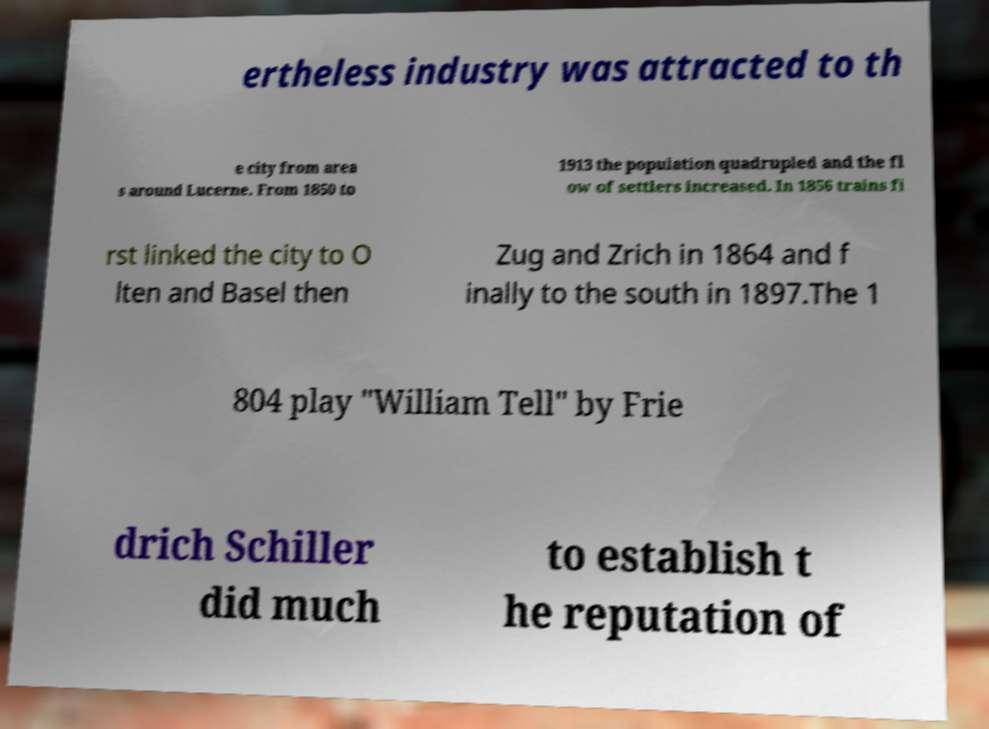Can you accurately transcribe the text from the provided image for me? ertheless industry was attracted to th e city from area s around Lucerne. From 1850 to 1913 the population quadrupled and the fl ow of settlers increased. In 1856 trains fi rst linked the city to O lten and Basel then Zug and Zrich in 1864 and f inally to the south in 1897.The 1 804 play "William Tell" by Frie drich Schiller did much to establish t he reputation of 